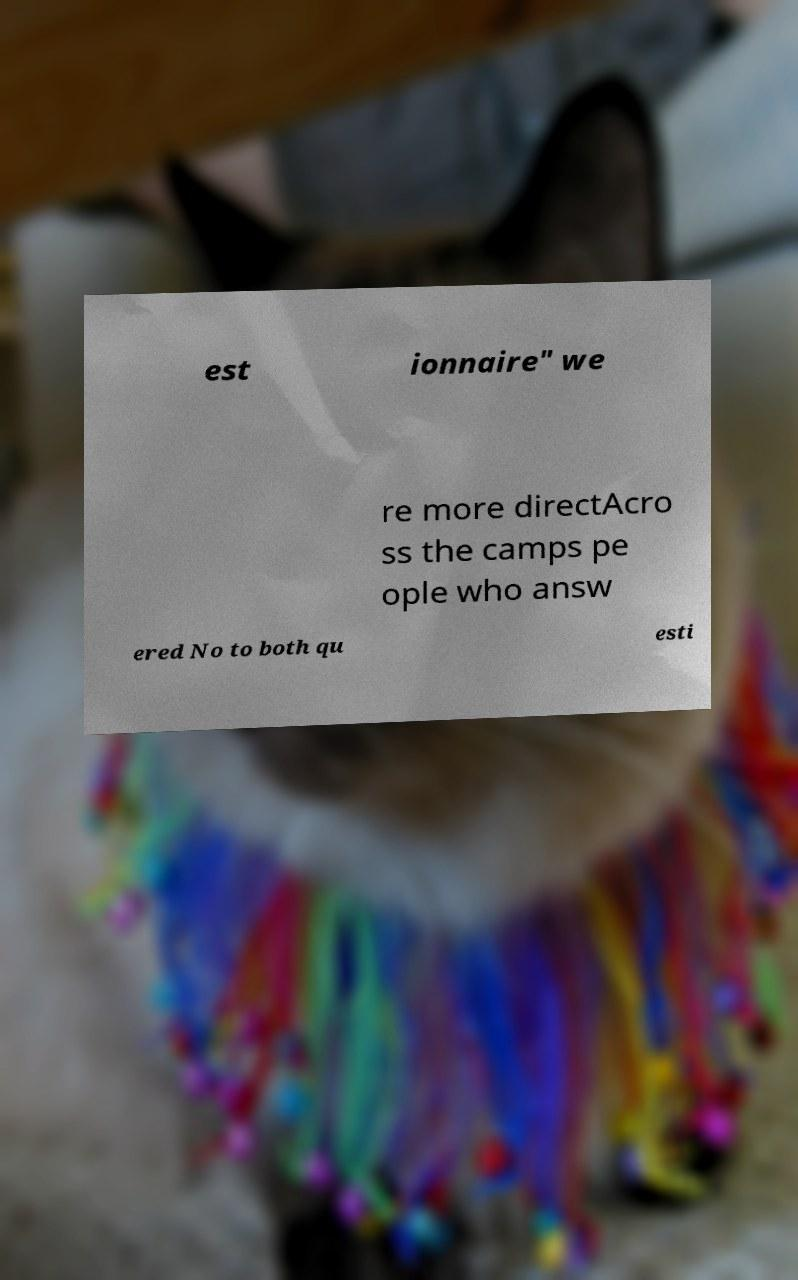What messages or text are displayed in this image? I need them in a readable, typed format. est ionnaire" we re more directAcro ss the camps pe ople who answ ered No to both qu esti 